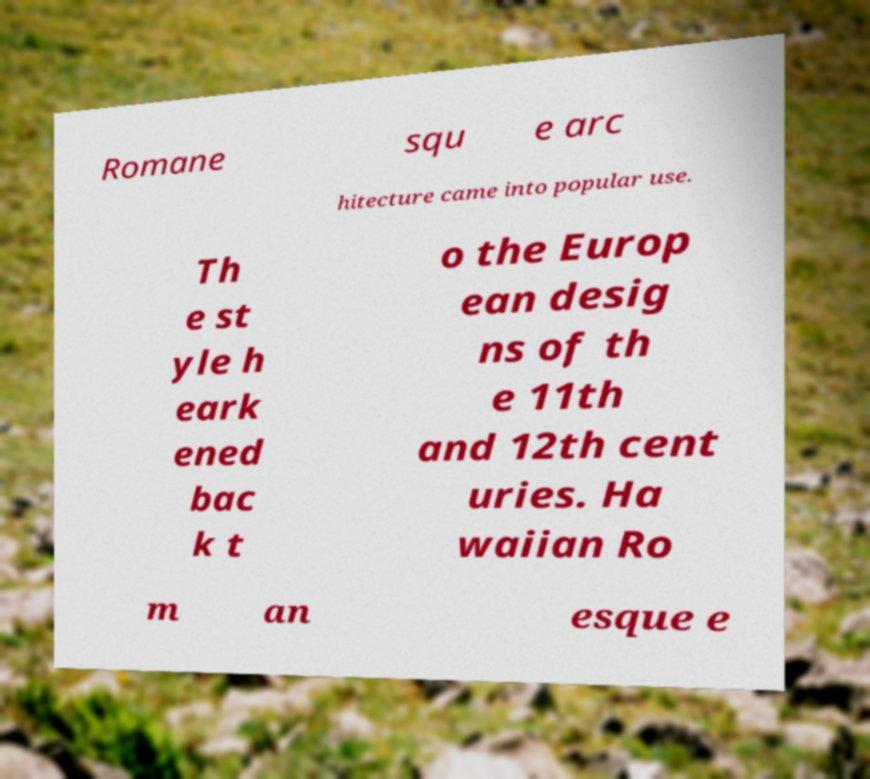Please identify and transcribe the text found in this image. Romane squ e arc hitecture came into popular use. Th e st yle h eark ened bac k t o the Europ ean desig ns of th e 11th and 12th cent uries. Ha waiian Ro m an esque e 